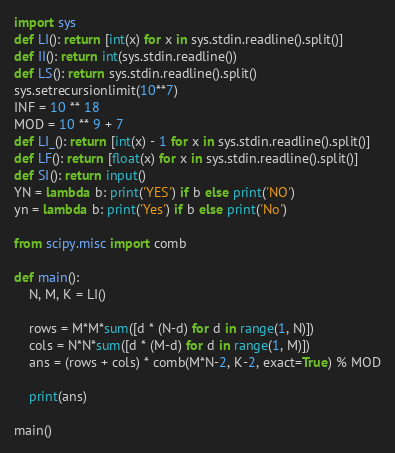<code> <loc_0><loc_0><loc_500><loc_500><_Python_>import sys
def LI(): return [int(x) for x in sys.stdin.readline().split()]
def II(): return int(sys.stdin.readline())
def LS(): return sys.stdin.readline().split()
sys.setrecursionlimit(10**7)
INF = 10 ** 18
MOD = 10 ** 9 + 7
def LI_(): return [int(x) - 1 for x in sys.stdin.readline().split()]
def LF(): return [float(x) for x in sys.stdin.readline().split()]
def SI(): return input()
YN = lambda b: print('YES') if b else print('NO')
yn = lambda b: print('Yes') if b else print('No')

from scipy.misc import comb

def main():
    N, M, K = LI()

    rows = M*M*sum([d * (N-d) for d in range(1, N)])
    cols = N*N*sum([d * (M-d) for d in range(1, M)])
    ans = (rows + cols) * comb(M*N-2, K-2, exact=True) % MOD

    print(ans)

main()</code> 